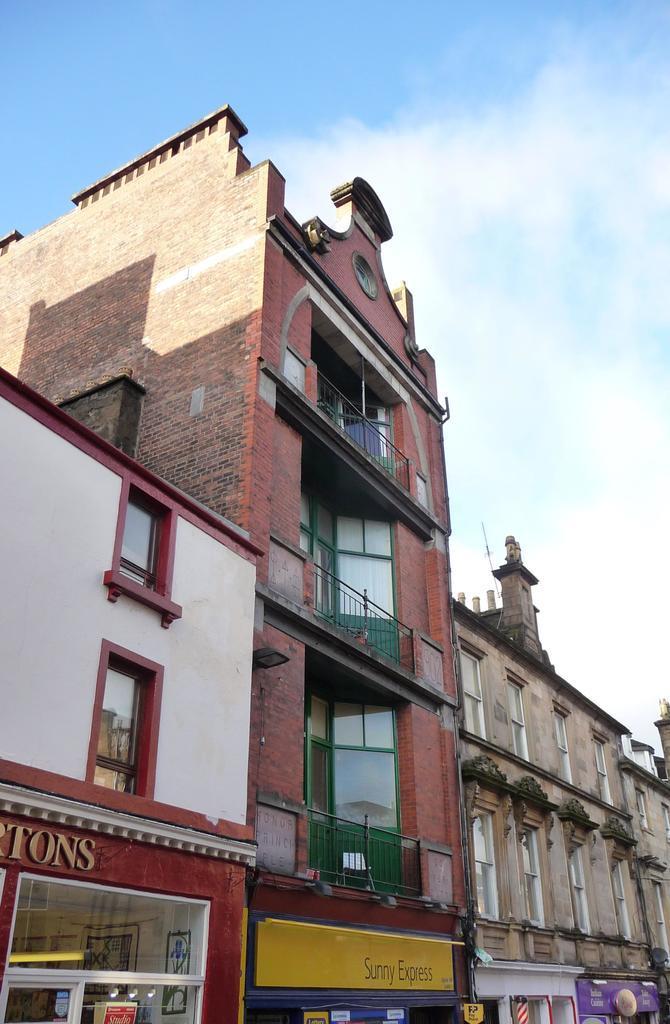Can you describe this image briefly? In this image, we can see there are buildings which are having windows and hoardings on the walls. In the background, there are clouds in the sky. 